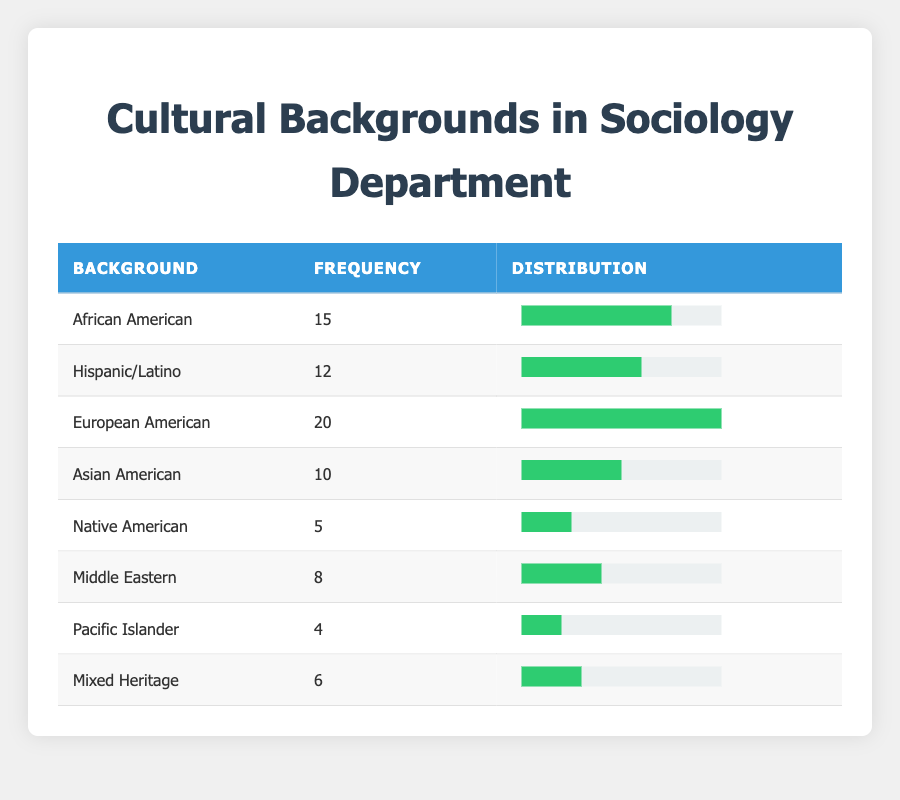What is the frequency of European American students? The table shows that the frequency for European American students is 20.
Answer: 20 How many students have a Hispanic/Latino background? According to the table, there are 12 students with a Hispanic/Latino background.
Answer: 12 What is the total number of students from Native American and Pacific Islander backgrounds combined? The frequency for Native American is 5 and for Pacific Islander is 4. Adding these gives 5 + 4 = 9.
Answer: 9 Is the frequency of Asian American students greater than that of Mixed Heritage students? The frequency for Asian American is 10, while the frequency for Mixed Heritage is 6. Since 10 is greater than 6, the answer is yes.
Answer: Yes What is the percentage representation of Hispanic/Latino students in relation to the total frequency of all students? The total frequency of all students is 20 + 15 + 12 + 10 + 5 + 8 + 4 + 6 = 90. Hispanic/Latino students have a frequency of 12. Calculating the percentage: (12/90) * 100 = 13.33%.
Answer: 13.33% Which cultural background has the least representation? The table indicates that Pacific Islander has the least representation with a frequency of 4, which is lower than all other backgrounds listed.
Answer: Pacific Islander What is the combined frequency of students from African American, Middle Eastern, and Mixed Heritage backgrounds? The frequency for African American is 15, Middle Eastern is 8, and Mixed Heritage is 6. Combining these gives 15 + 8 + 6 = 29.
Answer: 29 Are there more students from European American or Asian American backgrounds? The frequency for European American students is 20 and that for Asian American is 10. Since 20 is greater than 10, the answer is European American has more students.
Answer: European American What is the average frequency of cultural backgrounds in the table? To find the average, first sum all frequencies: 15 + 12 + 20 + 10 + 5 + 8 + 4 + 6 = 90. There are 8 cultural backgrounds, so the average is 90/8 = 11.25.
Answer: 11.25 